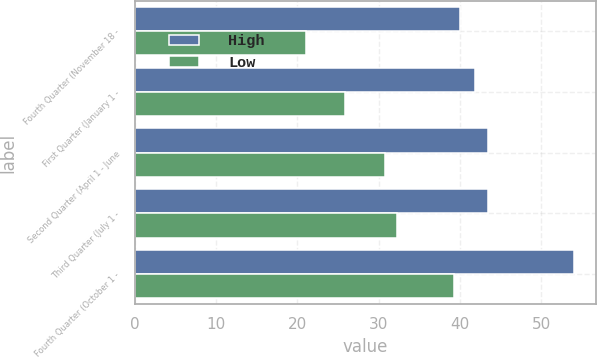<chart> <loc_0><loc_0><loc_500><loc_500><stacked_bar_chart><ecel><fcel>Fourth Quarter (November 18 -<fcel>First Quarter (January 1 -<fcel>Second Quarter (April 1 - June<fcel>Third Quarter (July 1 -<fcel>Fourth Quarter (October 1 -<nl><fcel>High<fcel>40<fcel>41.9<fcel>43.5<fcel>43.5<fcel>54<nl><fcel>Low<fcel>21.08<fcel>25.85<fcel>30.75<fcel>32.2<fcel>39.33<nl></chart> 